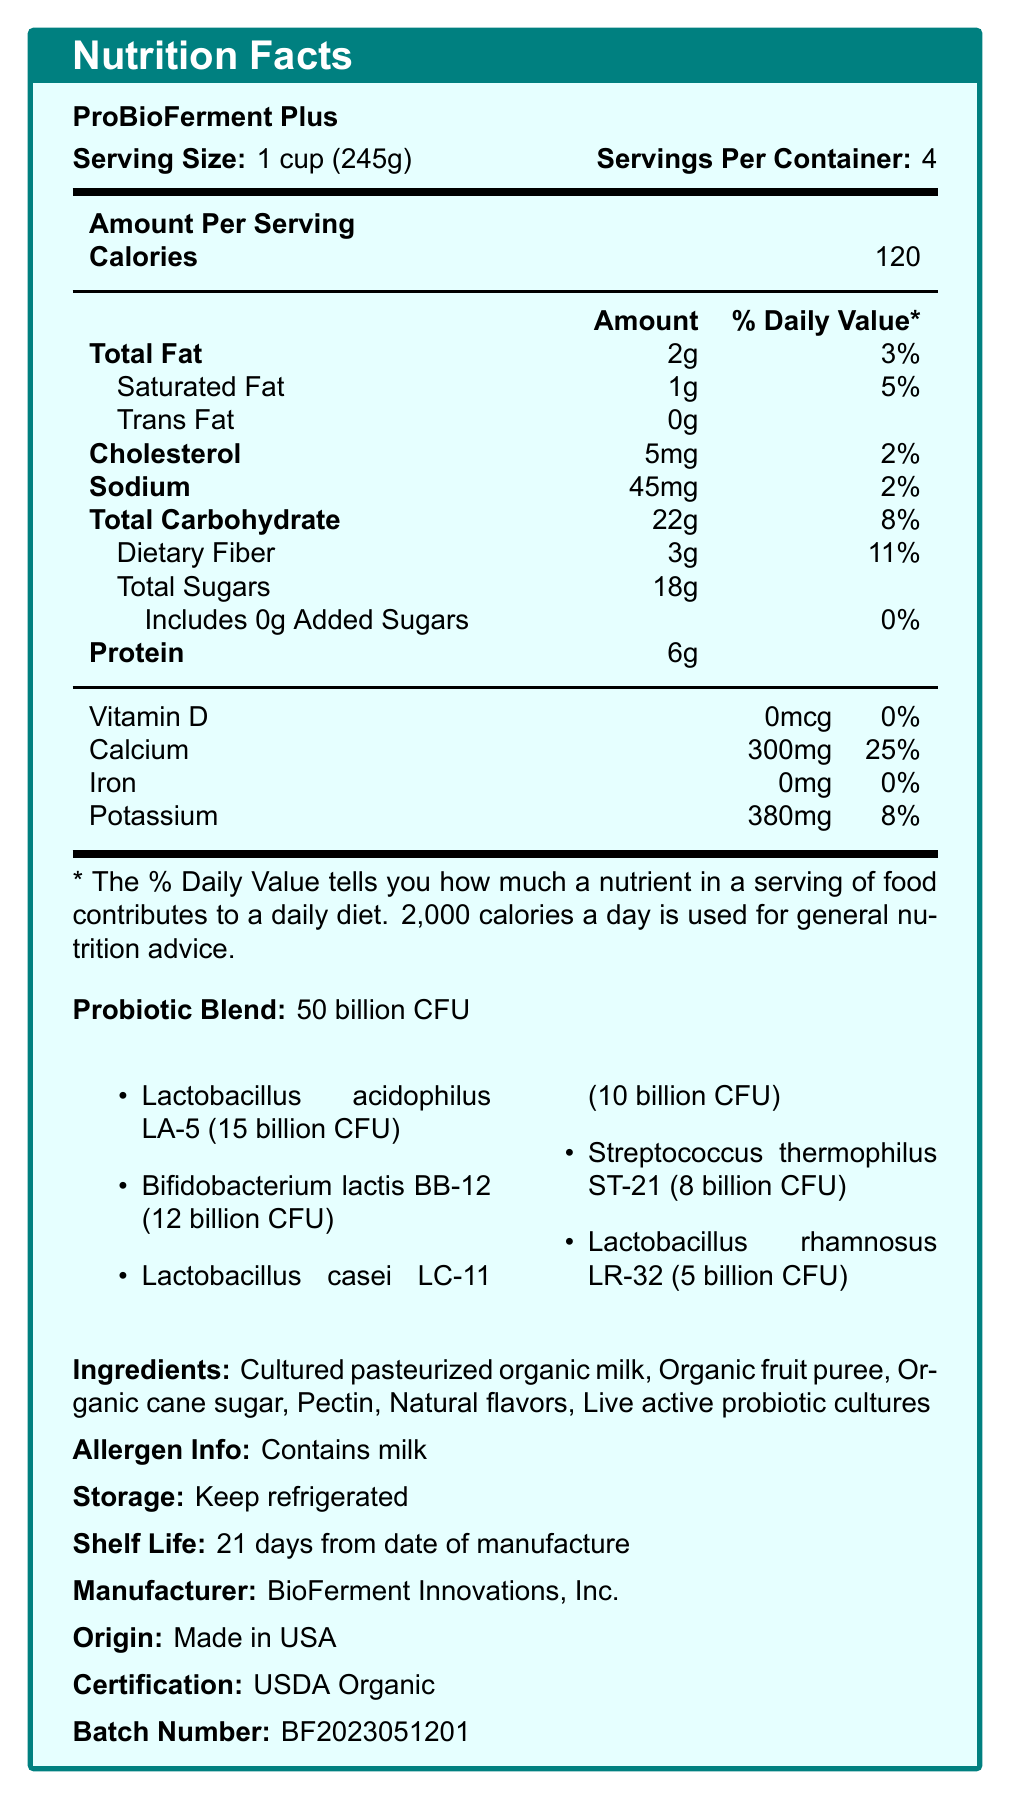what is the serving size for ProBioFerment Plus? The document specifies that the serving size is "1 cup (245g)".
Answer: 1 cup (245g) how many servings are in each container? The document indicates there are 4 servings per container.
Answer: 4 what percentage of the daily value of calcium is in one serving? The document lists the calcium content as "300mg" with a daily value of "25%".
Answer: 25% which probiotics are included in the blend and in what quantities? The document includes a list under the "Probiotic Blend" section that details each strain and its count.
Answer: Lactobacillus acidophilus LA-5 (15 billion CFU), Bifidobacterium lactis BB-12 (12 billion CFU), Lactobacillus casei LC-11 (10 billion CFU), Streptococcus thermophilus ST-21 (8 billion CFU), Lactobacillus rhamnosus LR-32 (5 billion CFU) how much protein is in a serving? The document shows "Protein: 6g" listed in the nutrition facts.
Answer: 6g what is the total carbohydrate content per serving? The document states "Total Carbohydrate: 22g".
Answer: 22g which of the following is a bacterial strain in the probiotic blend?
I. Lactobacillus acidophilus LA-5
II. Escherichia coli EC-6
III. Bifidobacterium lactis BB-12 The document lists Lactobacillus acidophilus LA-5 and Bifidobacterium lactis BB-12 as part of the probiotic blend. Escherichia coli EC-6 is not mentioned.
Answer: I and III how many calories are in one serving?
A. 60
B. 80
C. 120
D. 150 The document mentions that one serving contains 120 calories.
Answer: C what ingredient is listed first in the ingredients section?
A. Organic cane sugar
B. Cultured pasteurized organic milk
C. Pectin
D. Natural flavors The first ingredient listed is "Cultured pasteurized organic milk".
Answer: B does the product contain milk? The document under the "Allergen Info" states "Contains milk".
Answer: Yes describe the shelf life of ProBioFerment Plus. The document clearly states that the shelf life is "21 days from date of manufacture".
Answer: 21 days from date of manufacture can the document determine the expiration date of a specific batch? The shelf life is given, but without the manufacture date, the expiration date of a specific batch cannot be determined.
Answer: Cannot be determined summarize the essential information presented in the document. The document presents detailed nutritional information, including serving size, caloric content, nutrient breakdown, and probiotic strains. It also lists ingredients, allergen info, storage instructions, shelf life, manufacturer information, and certification status.
Answer: ProBioFerment Plus is a probiotic-rich fermented food product containing live active cultures. The serving size is 1 cup (245g), with 4 servings per container, providing 120 calories per serving. It contains 2g of total fat, 22g of carbohydrates, 6g of protein, and various vitamins and minerals. The probiotic blend consists of 50 billion CFU with detailed strains and counts. Ingredients include cultured pasteurized organic milk and various organic additives. It has a shelf life of 21 days, requires refrigeration, is certified USDA Organic, and is manufactured by BioFerment Innovations, Inc. 